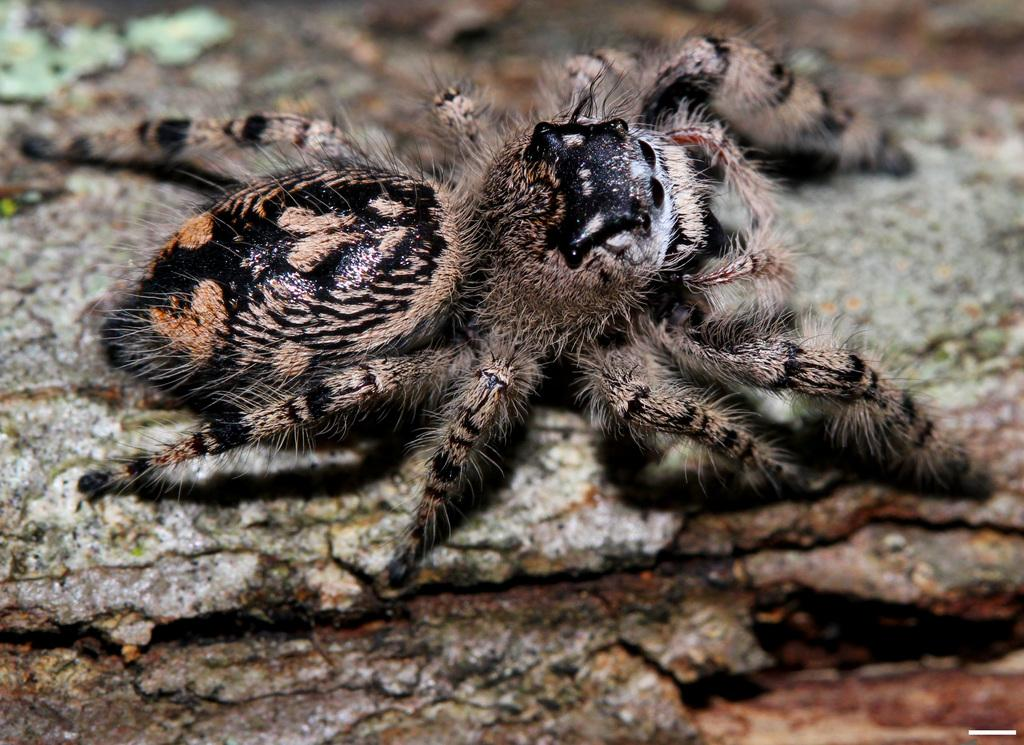What is the main subject of the image? There is an insect in the image. Where is the insect located? The insect is on a log. Can you describe the position of the insect in the image? The insect is in the center of the image. Can you tell me how many times the insect swings on the log in the image? There is no indication of the insect swinging on the log in the image. 